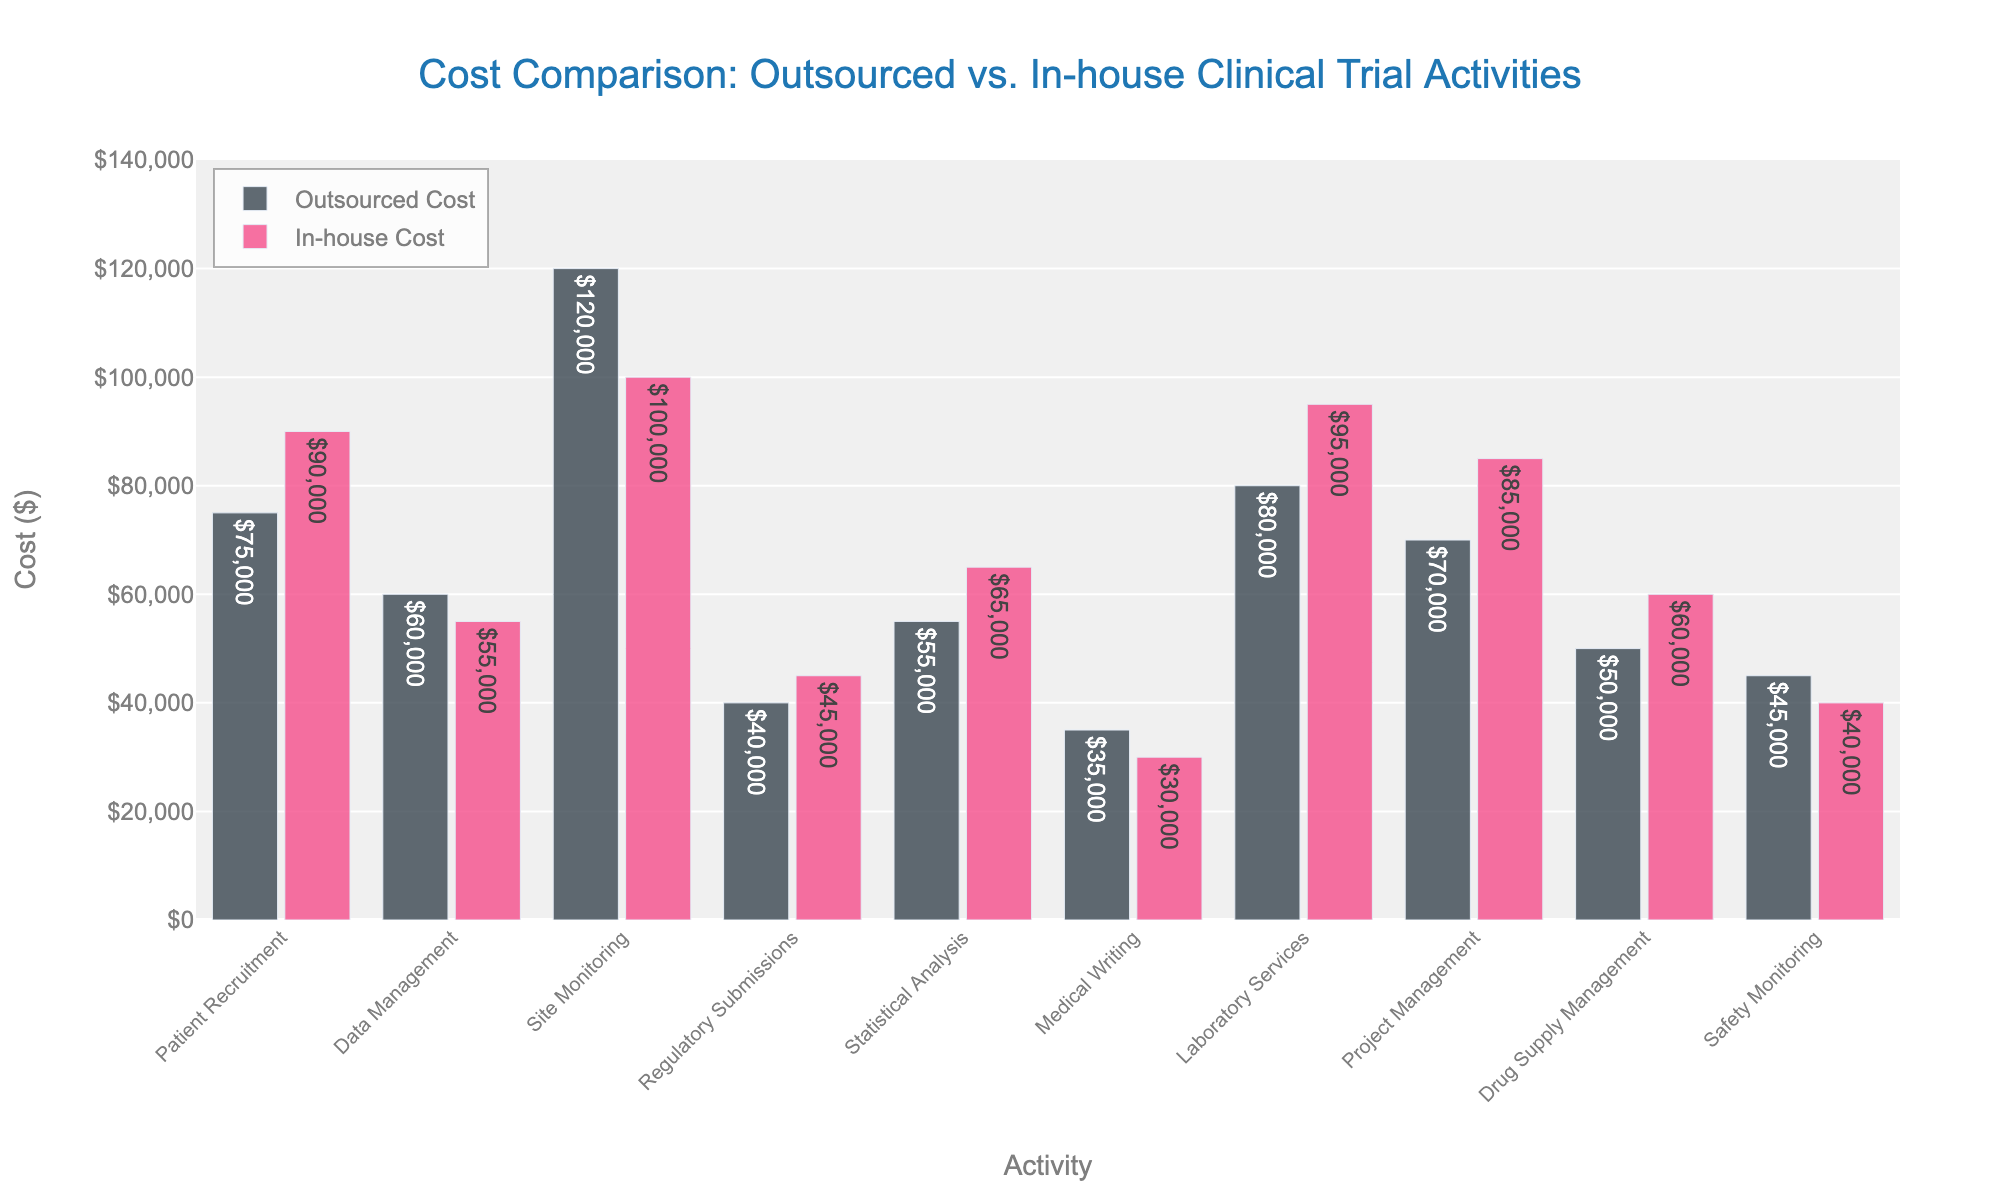What is the most expensive activity when conducted in-house? First, refer to the tallest pink bar, which represents the in-house cost across all activities. The highest in-house cost bar is for 'Site Monitoring' at $100,000.
Answer: Site Monitoring Which activity has the smallest cost difference between outsourced and in-house activities? To determine the smallest cost difference, compute the absolute difference for each activity. The difference is smallest for 'Regulatory Submissions' with $45,000 in-house and $40,000 outsourced, resulting in a $5,000 difference.
Answer: Regulatory Submissions What is the total cost of outsourced activities for 'Patient Recruitment' and 'Site Monitoring'? Sum the outsourced costs for 'Patient Recruitment' and 'Site Monitoring': $75,000 + $120,000 = $195,000.
Answer: $195,000 Which activity showed a higher cost when outsourced compared to in-house? Compare the bars for each activity to see if the black bar (outsourced cost) is taller than the pink bar (in-house cost). 'Data Management', 'Medical Writing', and 'Safety Monitoring' show higher outsourced costs compared to their in-house counterparts.
Answer: Data Management, Medical Writing, Safety Monitoring On average, which has a higher cost: outsourced activities or in-house activities? Calculate the average for both outsourced and in-house costs. The outsourced total is $620,000/10 = $62,000, and the in-house total is $646,000/10 = $64,600. The in-house activities have a higher average cost.
Answer: In-house activities For which activities do both outsourced and in-house costs exceed $70,000? Compare the bars where both heights exceed $70,000. 'Patient Recruitment', 'Site Monitoring', and 'Project Management' both exceed this threshold for their respective outsourced and in-house costs.
Answer: Patient Recruitment, Site Monitoring, Project Management By how much is the cost of outsourced 'Laboratory Services' cheaper than in-house 'Laboratory Services'? Subtract the cost of outsourced 'Laboratory Services' ($80,000) from the in-house 'Laboratory Services' ($95,000): $95,000 - $80,000 = $15,000.
Answer: $15,000 Which outsourced activity is the most cost-effective compared to its corresponding in-house activity? Determine which activity has the greatest cost-saving when outsourced by subtracting the outsourced cost from the in-house cost for each activity. 'Project Management' shows the greatest cost-saving of $15,000 when outsourced ($85,000 in-house vs. $70,000 outsourced).
Answer: Project Management What's the total combined cost for 'Drug Supply Management' when considering both outsourced and in-house prices? Add the costs for outsourced ($50,000) and in-house ($60,000) 'Drug Supply Management': $50,000 + $60,000 = $110,000.
Answer: $110,000 